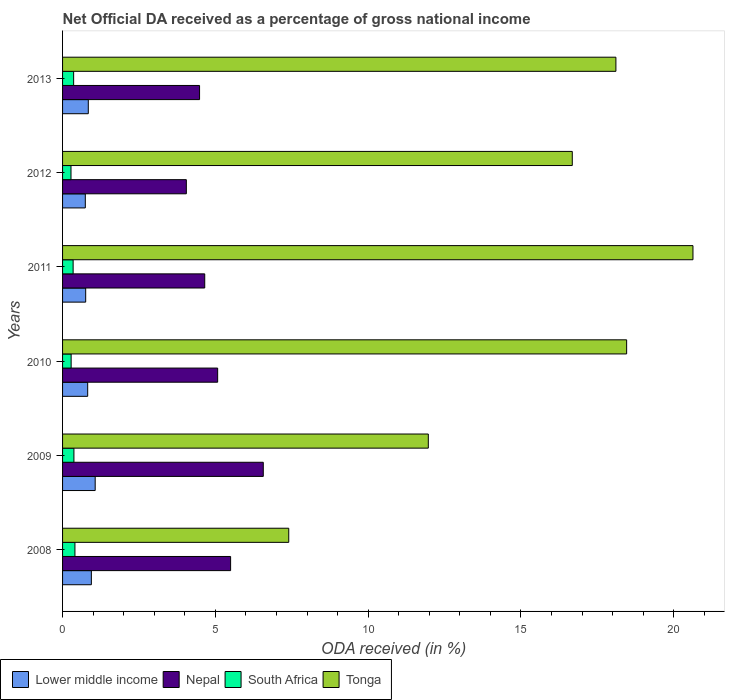How many bars are there on the 6th tick from the top?
Provide a short and direct response. 4. What is the label of the 2nd group of bars from the top?
Give a very brief answer. 2012. What is the net official DA received in Tonga in 2009?
Make the answer very short. 11.97. Across all years, what is the maximum net official DA received in Tonga?
Your answer should be compact. 20.63. Across all years, what is the minimum net official DA received in Nepal?
Provide a succinct answer. 4.05. In which year was the net official DA received in Nepal minimum?
Keep it short and to the point. 2012. What is the total net official DA received in Tonga in the graph?
Your response must be concise. 93.24. What is the difference between the net official DA received in Nepal in 2009 and that in 2013?
Your answer should be very brief. 2.08. What is the difference between the net official DA received in Nepal in 2010 and the net official DA received in Lower middle income in 2008?
Provide a succinct answer. 4.13. What is the average net official DA received in South Africa per year?
Provide a short and direct response. 0.34. In the year 2012, what is the difference between the net official DA received in Lower middle income and net official DA received in South Africa?
Provide a short and direct response. 0.47. In how many years, is the net official DA received in South Africa greater than 11 %?
Offer a very short reply. 0. What is the ratio of the net official DA received in South Africa in 2010 to that in 2012?
Make the answer very short. 1.02. Is the difference between the net official DA received in Lower middle income in 2008 and 2012 greater than the difference between the net official DA received in South Africa in 2008 and 2012?
Make the answer very short. Yes. What is the difference between the highest and the second highest net official DA received in Lower middle income?
Provide a short and direct response. 0.13. What is the difference between the highest and the lowest net official DA received in Nepal?
Provide a succinct answer. 2.52. Is the sum of the net official DA received in Tonga in 2010 and 2013 greater than the maximum net official DA received in Nepal across all years?
Provide a succinct answer. Yes. Is it the case that in every year, the sum of the net official DA received in Nepal and net official DA received in Tonga is greater than the sum of net official DA received in South Africa and net official DA received in Lower middle income?
Give a very brief answer. Yes. What does the 3rd bar from the top in 2008 represents?
Provide a short and direct response. Nepal. What does the 4th bar from the bottom in 2009 represents?
Keep it short and to the point. Tonga. Is it the case that in every year, the sum of the net official DA received in Lower middle income and net official DA received in Tonga is greater than the net official DA received in South Africa?
Offer a very short reply. Yes. How many years are there in the graph?
Provide a succinct answer. 6. Are the values on the major ticks of X-axis written in scientific E-notation?
Your answer should be very brief. No. Does the graph contain grids?
Offer a very short reply. No. How are the legend labels stacked?
Offer a terse response. Horizontal. What is the title of the graph?
Make the answer very short. Net Official DA received as a percentage of gross national income. What is the label or title of the X-axis?
Ensure brevity in your answer.  ODA received (in %). What is the ODA received (in %) in Lower middle income in 2008?
Provide a succinct answer. 0.94. What is the ODA received (in %) of Nepal in 2008?
Your answer should be very brief. 5.5. What is the ODA received (in %) in South Africa in 2008?
Ensure brevity in your answer.  0.4. What is the ODA received (in %) in Tonga in 2008?
Your answer should be compact. 7.4. What is the ODA received (in %) in Lower middle income in 2009?
Keep it short and to the point. 1.07. What is the ODA received (in %) of Nepal in 2009?
Ensure brevity in your answer.  6.57. What is the ODA received (in %) of South Africa in 2009?
Offer a very short reply. 0.37. What is the ODA received (in %) in Tonga in 2009?
Offer a terse response. 11.97. What is the ODA received (in %) of Lower middle income in 2010?
Make the answer very short. 0.82. What is the ODA received (in %) in Nepal in 2010?
Your answer should be compact. 5.08. What is the ODA received (in %) in South Africa in 2010?
Offer a terse response. 0.28. What is the ODA received (in %) in Tonga in 2010?
Ensure brevity in your answer.  18.46. What is the ODA received (in %) in Lower middle income in 2011?
Make the answer very short. 0.76. What is the ODA received (in %) in Nepal in 2011?
Provide a short and direct response. 4.65. What is the ODA received (in %) in South Africa in 2011?
Keep it short and to the point. 0.35. What is the ODA received (in %) of Tonga in 2011?
Your response must be concise. 20.63. What is the ODA received (in %) in Lower middle income in 2012?
Keep it short and to the point. 0.74. What is the ODA received (in %) of Nepal in 2012?
Make the answer very short. 4.05. What is the ODA received (in %) in South Africa in 2012?
Your answer should be very brief. 0.28. What is the ODA received (in %) of Tonga in 2012?
Give a very brief answer. 16.68. What is the ODA received (in %) in Lower middle income in 2013?
Your answer should be very brief. 0.84. What is the ODA received (in %) in Nepal in 2013?
Give a very brief answer. 4.48. What is the ODA received (in %) of South Africa in 2013?
Provide a short and direct response. 0.36. What is the ODA received (in %) of Tonga in 2013?
Ensure brevity in your answer.  18.11. Across all years, what is the maximum ODA received (in %) in Lower middle income?
Give a very brief answer. 1.07. Across all years, what is the maximum ODA received (in %) of Nepal?
Your response must be concise. 6.57. Across all years, what is the maximum ODA received (in %) of South Africa?
Keep it short and to the point. 0.4. Across all years, what is the maximum ODA received (in %) of Tonga?
Provide a succinct answer. 20.63. Across all years, what is the minimum ODA received (in %) in Lower middle income?
Keep it short and to the point. 0.74. Across all years, what is the minimum ODA received (in %) of Nepal?
Offer a very short reply. 4.05. Across all years, what is the minimum ODA received (in %) in South Africa?
Ensure brevity in your answer.  0.28. Across all years, what is the minimum ODA received (in %) of Tonga?
Make the answer very short. 7.4. What is the total ODA received (in %) in Lower middle income in the graph?
Offer a terse response. 5.17. What is the total ODA received (in %) in Nepal in the graph?
Ensure brevity in your answer.  30.33. What is the total ODA received (in %) of South Africa in the graph?
Offer a terse response. 2.04. What is the total ODA received (in %) of Tonga in the graph?
Your answer should be very brief. 93.24. What is the difference between the ODA received (in %) of Lower middle income in 2008 and that in 2009?
Your answer should be compact. -0.13. What is the difference between the ODA received (in %) of Nepal in 2008 and that in 2009?
Give a very brief answer. -1.07. What is the difference between the ODA received (in %) in South Africa in 2008 and that in 2009?
Offer a very short reply. 0.03. What is the difference between the ODA received (in %) in Tonga in 2008 and that in 2009?
Ensure brevity in your answer.  -4.57. What is the difference between the ODA received (in %) in Lower middle income in 2008 and that in 2010?
Keep it short and to the point. 0.12. What is the difference between the ODA received (in %) of Nepal in 2008 and that in 2010?
Offer a terse response. 0.42. What is the difference between the ODA received (in %) of South Africa in 2008 and that in 2010?
Provide a succinct answer. 0.12. What is the difference between the ODA received (in %) of Tonga in 2008 and that in 2010?
Keep it short and to the point. -11.06. What is the difference between the ODA received (in %) of Lower middle income in 2008 and that in 2011?
Offer a terse response. 0.19. What is the difference between the ODA received (in %) in Nepal in 2008 and that in 2011?
Your answer should be compact. 0.85. What is the difference between the ODA received (in %) of South Africa in 2008 and that in 2011?
Offer a terse response. 0.06. What is the difference between the ODA received (in %) in Tonga in 2008 and that in 2011?
Make the answer very short. -13.23. What is the difference between the ODA received (in %) of Lower middle income in 2008 and that in 2012?
Provide a short and direct response. 0.2. What is the difference between the ODA received (in %) in Nepal in 2008 and that in 2012?
Your answer should be very brief. 1.45. What is the difference between the ODA received (in %) in South Africa in 2008 and that in 2012?
Ensure brevity in your answer.  0.13. What is the difference between the ODA received (in %) of Tonga in 2008 and that in 2012?
Offer a terse response. -9.28. What is the difference between the ODA received (in %) in Lower middle income in 2008 and that in 2013?
Offer a very short reply. 0.1. What is the difference between the ODA received (in %) of Nepal in 2008 and that in 2013?
Ensure brevity in your answer.  1.02. What is the difference between the ODA received (in %) of South Africa in 2008 and that in 2013?
Provide a short and direct response. 0.04. What is the difference between the ODA received (in %) in Tonga in 2008 and that in 2013?
Ensure brevity in your answer.  -10.71. What is the difference between the ODA received (in %) of Lower middle income in 2009 and that in 2010?
Your answer should be compact. 0.25. What is the difference between the ODA received (in %) in Nepal in 2009 and that in 2010?
Make the answer very short. 1.49. What is the difference between the ODA received (in %) in South Africa in 2009 and that in 2010?
Your answer should be very brief. 0.09. What is the difference between the ODA received (in %) in Tonga in 2009 and that in 2010?
Make the answer very short. -6.49. What is the difference between the ODA received (in %) in Lower middle income in 2009 and that in 2011?
Give a very brief answer. 0.31. What is the difference between the ODA received (in %) in Nepal in 2009 and that in 2011?
Make the answer very short. 1.92. What is the difference between the ODA received (in %) of South Africa in 2009 and that in 2011?
Make the answer very short. 0.03. What is the difference between the ODA received (in %) in Tonga in 2009 and that in 2011?
Offer a very short reply. -8.66. What is the difference between the ODA received (in %) of Lower middle income in 2009 and that in 2012?
Keep it short and to the point. 0.32. What is the difference between the ODA received (in %) in Nepal in 2009 and that in 2012?
Give a very brief answer. 2.52. What is the difference between the ODA received (in %) in South Africa in 2009 and that in 2012?
Make the answer very short. 0.1. What is the difference between the ODA received (in %) in Tonga in 2009 and that in 2012?
Ensure brevity in your answer.  -4.71. What is the difference between the ODA received (in %) of Lower middle income in 2009 and that in 2013?
Offer a very short reply. 0.23. What is the difference between the ODA received (in %) in Nepal in 2009 and that in 2013?
Your answer should be compact. 2.08. What is the difference between the ODA received (in %) in South Africa in 2009 and that in 2013?
Keep it short and to the point. 0.01. What is the difference between the ODA received (in %) of Tonga in 2009 and that in 2013?
Your response must be concise. -6.14. What is the difference between the ODA received (in %) in Lower middle income in 2010 and that in 2011?
Offer a very short reply. 0.07. What is the difference between the ODA received (in %) in Nepal in 2010 and that in 2011?
Offer a terse response. 0.42. What is the difference between the ODA received (in %) in South Africa in 2010 and that in 2011?
Your response must be concise. -0.07. What is the difference between the ODA received (in %) of Tonga in 2010 and that in 2011?
Offer a terse response. -2.17. What is the difference between the ODA received (in %) in Lower middle income in 2010 and that in 2012?
Your answer should be compact. 0.08. What is the difference between the ODA received (in %) of Nepal in 2010 and that in 2012?
Your response must be concise. 1.02. What is the difference between the ODA received (in %) of South Africa in 2010 and that in 2012?
Give a very brief answer. 0. What is the difference between the ODA received (in %) of Tonga in 2010 and that in 2012?
Offer a terse response. 1.78. What is the difference between the ODA received (in %) of Lower middle income in 2010 and that in 2013?
Offer a very short reply. -0.02. What is the difference between the ODA received (in %) in Nepal in 2010 and that in 2013?
Your answer should be very brief. 0.59. What is the difference between the ODA received (in %) of South Africa in 2010 and that in 2013?
Keep it short and to the point. -0.08. What is the difference between the ODA received (in %) of Tonga in 2010 and that in 2013?
Offer a very short reply. 0.35. What is the difference between the ODA received (in %) of Lower middle income in 2011 and that in 2012?
Your answer should be very brief. 0.01. What is the difference between the ODA received (in %) in Nepal in 2011 and that in 2012?
Your response must be concise. 0.6. What is the difference between the ODA received (in %) in South Africa in 2011 and that in 2012?
Your answer should be compact. 0.07. What is the difference between the ODA received (in %) of Tonga in 2011 and that in 2012?
Provide a succinct answer. 3.95. What is the difference between the ODA received (in %) in Lower middle income in 2011 and that in 2013?
Your answer should be compact. -0.09. What is the difference between the ODA received (in %) in Nepal in 2011 and that in 2013?
Your response must be concise. 0.17. What is the difference between the ODA received (in %) in South Africa in 2011 and that in 2013?
Your response must be concise. -0.02. What is the difference between the ODA received (in %) in Tonga in 2011 and that in 2013?
Offer a terse response. 2.52. What is the difference between the ODA received (in %) in Lower middle income in 2012 and that in 2013?
Provide a short and direct response. -0.1. What is the difference between the ODA received (in %) in Nepal in 2012 and that in 2013?
Your answer should be very brief. -0.43. What is the difference between the ODA received (in %) of South Africa in 2012 and that in 2013?
Your answer should be compact. -0.09. What is the difference between the ODA received (in %) in Tonga in 2012 and that in 2013?
Keep it short and to the point. -1.43. What is the difference between the ODA received (in %) in Lower middle income in 2008 and the ODA received (in %) in Nepal in 2009?
Your answer should be compact. -5.63. What is the difference between the ODA received (in %) of Lower middle income in 2008 and the ODA received (in %) of South Africa in 2009?
Your response must be concise. 0.57. What is the difference between the ODA received (in %) in Lower middle income in 2008 and the ODA received (in %) in Tonga in 2009?
Make the answer very short. -11.03. What is the difference between the ODA received (in %) of Nepal in 2008 and the ODA received (in %) of South Africa in 2009?
Offer a very short reply. 5.13. What is the difference between the ODA received (in %) in Nepal in 2008 and the ODA received (in %) in Tonga in 2009?
Offer a very short reply. -6.47. What is the difference between the ODA received (in %) in South Africa in 2008 and the ODA received (in %) in Tonga in 2009?
Keep it short and to the point. -11.56. What is the difference between the ODA received (in %) of Lower middle income in 2008 and the ODA received (in %) of Nepal in 2010?
Your response must be concise. -4.13. What is the difference between the ODA received (in %) in Lower middle income in 2008 and the ODA received (in %) in South Africa in 2010?
Give a very brief answer. 0.66. What is the difference between the ODA received (in %) of Lower middle income in 2008 and the ODA received (in %) of Tonga in 2010?
Offer a terse response. -17.52. What is the difference between the ODA received (in %) in Nepal in 2008 and the ODA received (in %) in South Africa in 2010?
Your answer should be compact. 5.22. What is the difference between the ODA received (in %) of Nepal in 2008 and the ODA received (in %) of Tonga in 2010?
Provide a short and direct response. -12.96. What is the difference between the ODA received (in %) of South Africa in 2008 and the ODA received (in %) of Tonga in 2010?
Provide a short and direct response. -18.05. What is the difference between the ODA received (in %) of Lower middle income in 2008 and the ODA received (in %) of Nepal in 2011?
Keep it short and to the point. -3.71. What is the difference between the ODA received (in %) in Lower middle income in 2008 and the ODA received (in %) in South Africa in 2011?
Give a very brief answer. 0.6. What is the difference between the ODA received (in %) of Lower middle income in 2008 and the ODA received (in %) of Tonga in 2011?
Keep it short and to the point. -19.69. What is the difference between the ODA received (in %) of Nepal in 2008 and the ODA received (in %) of South Africa in 2011?
Ensure brevity in your answer.  5.15. What is the difference between the ODA received (in %) in Nepal in 2008 and the ODA received (in %) in Tonga in 2011?
Offer a terse response. -15.13. What is the difference between the ODA received (in %) in South Africa in 2008 and the ODA received (in %) in Tonga in 2011?
Your response must be concise. -20.22. What is the difference between the ODA received (in %) of Lower middle income in 2008 and the ODA received (in %) of Nepal in 2012?
Your answer should be very brief. -3.11. What is the difference between the ODA received (in %) in Lower middle income in 2008 and the ODA received (in %) in South Africa in 2012?
Your answer should be very brief. 0.67. What is the difference between the ODA received (in %) in Lower middle income in 2008 and the ODA received (in %) in Tonga in 2012?
Offer a very short reply. -15.74. What is the difference between the ODA received (in %) in Nepal in 2008 and the ODA received (in %) in South Africa in 2012?
Your answer should be compact. 5.22. What is the difference between the ODA received (in %) in Nepal in 2008 and the ODA received (in %) in Tonga in 2012?
Offer a very short reply. -11.18. What is the difference between the ODA received (in %) in South Africa in 2008 and the ODA received (in %) in Tonga in 2012?
Offer a very short reply. -16.27. What is the difference between the ODA received (in %) in Lower middle income in 2008 and the ODA received (in %) in Nepal in 2013?
Your response must be concise. -3.54. What is the difference between the ODA received (in %) in Lower middle income in 2008 and the ODA received (in %) in South Africa in 2013?
Offer a very short reply. 0.58. What is the difference between the ODA received (in %) of Lower middle income in 2008 and the ODA received (in %) of Tonga in 2013?
Your answer should be very brief. -17.16. What is the difference between the ODA received (in %) in Nepal in 2008 and the ODA received (in %) in South Africa in 2013?
Your answer should be very brief. 5.14. What is the difference between the ODA received (in %) in Nepal in 2008 and the ODA received (in %) in Tonga in 2013?
Make the answer very short. -12.61. What is the difference between the ODA received (in %) of South Africa in 2008 and the ODA received (in %) of Tonga in 2013?
Make the answer very short. -17.7. What is the difference between the ODA received (in %) in Lower middle income in 2009 and the ODA received (in %) in Nepal in 2010?
Provide a succinct answer. -4.01. What is the difference between the ODA received (in %) of Lower middle income in 2009 and the ODA received (in %) of South Africa in 2010?
Keep it short and to the point. 0.79. What is the difference between the ODA received (in %) of Lower middle income in 2009 and the ODA received (in %) of Tonga in 2010?
Offer a terse response. -17.39. What is the difference between the ODA received (in %) of Nepal in 2009 and the ODA received (in %) of South Africa in 2010?
Your answer should be compact. 6.29. What is the difference between the ODA received (in %) in Nepal in 2009 and the ODA received (in %) in Tonga in 2010?
Provide a short and direct response. -11.89. What is the difference between the ODA received (in %) in South Africa in 2009 and the ODA received (in %) in Tonga in 2010?
Keep it short and to the point. -18.09. What is the difference between the ODA received (in %) in Lower middle income in 2009 and the ODA received (in %) in Nepal in 2011?
Offer a very short reply. -3.58. What is the difference between the ODA received (in %) in Lower middle income in 2009 and the ODA received (in %) in South Africa in 2011?
Provide a succinct answer. 0.72. What is the difference between the ODA received (in %) in Lower middle income in 2009 and the ODA received (in %) in Tonga in 2011?
Provide a short and direct response. -19.56. What is the difference between the ODA received (in %) of Nepal in 2009 and the ODA received (in %) of South Africa in 2011?
Ensure brevity in your answer.  6.22. What is the difference between the ODA received (in %) of Nepal in 2009 and the ODA received (in %) of Tonga in 2011?
Offer a very short reply. -14.06. What is the difference between the ODA received (in %) of South Africa in 2009 and the ODA received (in %) of Tonga in 2011?
Make the answer very short. -20.26. What is the difference between the ODA received (in %) in Lower middle income in 2009 and the ODA received (in %) in Nepal in 2012?
Offer a terse response. -2.98. What is the difference between the ODA received (in %) of Lower middle income in 2009 and the ODA received (in %) of South Africa in 2012?
Provide a short and direct response. 0.79. What is the difference between the ODA received (in %) in Lower middle income in 2009 and the ODA received (in %) in Tonga in 2012?
Provide a succinct answer. -15.61. What is the difference between the ODA received (in %) of Nepal in 2009 and the ODA received (in %) of South Africa in 2012?
Give a very brief answer. 6.29. What is the difference between the ODA received (in %) in Nepal in 2009 and the ODA received (in %) in Tonga in 2012?
Keep it short and to the point. -10.11. What is the difference between the ODA received (in %) of South Africa in 2009 and the ODA received (in %) of Tonga in 2012?
Provide a succinct answer. -16.31. What is the difference between the ODA received (in %) of Lower middle income in 2009 and the ODA received (in %) of Nepal in 2013?
Provide a short and direct response. -3.42. What is the difference between the ODA received (in %) in Lower middle income in 2009 and the ODA received (in %) in South Africa in 2013?
Keep it short and to the point. 0.7. What is the difference between the ODA received (in %) in Lower middle income in 2009 and the ODA received (in %) in Tonga in 2013?
Provide a short and direct response. -17.04. What is the difference between the ODA received (in %) in Nepal in 2009 and the ODA received (in %) in South Africa in 2013?
Offer a terse response. 6.21. What is the difference between the ODA received (in %) in Nepal in 2009 and the ODA received (in %) in Tonga in 2013?
Keep it short and to the point. -11.54. What is the difference between the ODA received (in %) of South Africa in 2009 and the ODA received (in %) of Tonga in 2013?
Ensure brevity in your answer.  -17.73. What is the difference between the ODA received (in %) of Lower middle income in 2010 and the ODA received (in %) of Nepal in 2011?
Your answer should be compact. -3.83. What is the difference between the ODA received (in %) of Lower middle income in 2010 and the ODA received (in %) of South Africa in 2011?
Your answer should be compact. 0.48. What is the difference between the ODA received (in %) in Lower middle income in 2010 and the ODA received (in %) in Tonga in 2011?
Make the answer very short. -19.81. What is the difference between the ODA received (in %) in Nepal in 2010 and the ODA received (in %) in South Africa in 2011?
Your response must be concise. 4.73. What is the difference between the ODA received (in %) in Nepal in 2010 and the ODA received (in %) in Tonga in 2011?
Provide a short and direct response. -15.55. What is the difference between the ODA received (in %) in South Africa in 2010 and the ODA received (in %) in Tonga in 2011?
Offer a very short reply. -20.35. What is the difference between the ODA received (in %) of Lower middle income in 2010 and the ODA received (in %) of Nepal in 2012?
Provide a succinct answer. -3.23. What is the difference between the ODA received (in %) in Lower middle income in 2010 and the ODA received (in %) in South Africa in 2012?
Your answer should be very brief. 0.55. What is the difference between the ODA received (in %) in Lower middle income in 2010 and the ODA received (in %) in Tonga in 2012?
Make the answer very short. -15.86. What is the difference between the ODA received (in %) in Nepal in 2010 and the ODA received (in %) in South Africa in 2012?
Your answer should be compact. 4.8. What is the difference between the ODA received (in %) in Nepal in 2010 and the ODA received (in %) in Tonga in 2012?
Keep it short and to the point. -11.6. What is the difference between the ODA received (in %) in South Africa in 2010 and the ODA received (in %) in Tonga in 2012?
Your answer should be very brief. -16.4. What is the difference between the ODA received (in %) of Lower middle income in 2010 and the ODA received (in %) of Nepal in 2013?
Your answer should be compact. -3.66. What is the difference between the ODA received (in %) in Lower middle income in 2010 and the ODA received (in %) in South Africa in 2013?
Your response must be concise. 0.46. What is the difference between the ODA received (in %) in Lower middle income in 2010 and the ODA received (in %) in Tonga in 2013?
Provide a short and direct response. -17.28. What is the difference between the ODA received (in %) of Nepal in 2010 and the ODA received (in %) of South Africa in 2013?
Your answer should be compact. 4.71. What is the difference between the ODA received (in %) in Nepal in 2010 and the ODA received (in %) in Tonga in 2013?
Ensure brevity in your answer.  -13.03. What is the difference between the ODA received (in %) in South Africa in 2010 and the ODA received (in %) in Tonga in 2013?
Keep it short and to the point. -17.83. What is the difference between the ODA received (in %) in Lower middle income in 2011 and the ODA received (in %) in Nepal in 2012?
Ensure brevity in your answer.  -3.29. What is the difference between the ODA received (in %) in Lower middle income in 2011 and the ODA received (in %) in South Africa in 2012?
Keep it short and to the point. 0.48. What is the difference between the ODA received (in %) of Lower middle income in 2011 and the ODA received (in %) of Tonga in 2012?
Provide a short and direct response. -15.92. What is the difference between the ODA received (in %) in Nepal in 2011 and the ODA received (in %) in South Africa in 2012?
Ensure brevity in your answer.  4.38. What is the difference between the ODA received (in %) of Nepal in 2011 and the ODA received (in %) of Tonga in 2012?
Offer a very short reply. -12.03. What is the difference between the ODA received (in %) of South Africa in 2011 and the ODA received (in %) of Tonga in 2012?
Give a very brief answer. -16.33. What is the difference between the ODA received (in %) of Lower middle income in 2011 and the ODA received (in %) of Nepal in 2013?
Your response must be concise. -3.73. What is the difference between the ODA received (in %) in Lower middle income in 2011 and the ODA received (in %) in South Africa in 2013?
Make the answer very short. 0.39. What is the difference between the ODA received (in %) in Lower middle income in 2011 and the ODA received (in %) in Tonga in 2013?
Give a very brief answer. -17.35. What is the difference between the ODA received (in %) of Nepal in 2011 and the ODA received (in %) of South Africa in 2013?
Your answer should be compact. 4.29. What is the difference between the ODA received (in %) of Nepal in 2011 and the ODA received (in %) of Tonga in 2013?
Provide a succinct answer. -13.45. What is the difference between the ODA received (in %) in South Africa in 2011 and the ODA received (in %) in Tonga in 2013?
Offer a very short reply. -17.76. What is the difference between the ODA received (in %) in Lower middle income in 2012 and the ODA received (in %) in Nepal in 2013?
Provide a succinct answer. -3.74. What is the difference between the ODA received (in %) in Lower middle income in 2012 and the ODA received (in %) in South Africa in 2013?
Make the answer very short. 0.38. What is the difference between the ODA received (in %) of Lower middle income in 2012 and the ODA received (in %) of Tonga in 2013?
Give a very brief answer. -17.36. What is the difference between the ODA received (in %) in Nepal in 2012 and the ODA received (in %) in South Africa in 2013?
Your answer should be very brief. 3.69. What is the difference between the ODA received (in %) in Nepal in 2012 and the ODA received (in %) in Tonga in 2013?
Make the answer very short. -14.06. What is the difference between the ODA received (in %) of South Africa in 2012 and the ODA received (in %) of Tonga in 2013?
Give a very brief answer. -17.83. What is the average ODA received (in %) of Lower middle income per year?
Keep it short and to the point. 0.86. What is the average ODA received (in %) of Nepal per year?
Your answer should be compact. 5.05. What is the average ODA received (in %) in South Africa per year?
Offer a terse response. 0.34. What is the average ODA received (in %) in Tonga per year?
Your response must be concise. 15.54. In the year 2008, what is the difference between the ODA received (in %) of Lower middle income and ODA received (in %) of Nepal?
Keep it short and to the point. -4.56. In the year 2008, what is the difference between the ODA received (in %) in Lower middle income and ODA received (in %) in South Africa?
Provide a short and direct response. 0.54. In the year 2008, what is the difference between the ODA received (in %) of Lower middle income and ODA received (in %) of Tonga?
Give a very brief answer. -6.46. In the year 2008, what is the difference between the ODA received (in %) of Nepal and ODA received (in %) of South Africa?
Keep it short and to the point. 5.09. In the year 2008, what is the difference between the ODA received (in %) of Nepal and ODA received (in %) of Tonga?
Keep it short and to the point. -1.9. In the year 2008, what is the difference between the ODA received (in %) in South Africa and ODA received (in %) in Tonga?
Make the answer very short. -7. In the year 2009, what is the difference between the ODA received (in %) in Lower middle income and ODA received (in %) in Nepal?
Your response must be concise. -5.5. In the year 2009, what is the difference between the ODA received (in %) of Lower middle income and ODA received (in %) of South Africa?
Provide a succinct answer. 0.7. In the year 2009, what is the difference between the ODA received (in %) of Lower middle income and ODA received (in %) of Tonga?
Your answer should be very brief. -10.9. In the year 2009, what is the difference between the ODA received (in %) in Nepal and ODA received (in %) in South Africa?
Give a very brief answer. 6.2. In the year 2009, what is the difference between the ODA received (in %) of Nepal and ODA received (in %) of Tonga?
Offer a terse response. -5.4. In the year 2009, what is the difference between the ODA received (in %) in South Africa and ODA received (in %) in Tonga?
Offer a very short reply. -11.6. In the year 2010, what is the difference between the ODA received (in %) in Lower middle income and ODA received (in %) in Nepal?
Keep it short and to the point. -4.25. In the year 2010, what is the difference between the ODA received (in %) in Lower middle income and ODA received (in %) in South Africa?
Ensure brevity in your answer.  0.54. In the year 2010, what is the difference between the ODA received (in %) in Lower middle income and ODA received (in %) in Tonga?
Your answer should be very brief. -17.64. In the year 2010, what is the difference between the ODA received (in %) in Nepal and ODA received (in %) in South Africa?
Offer a very short reply. 4.79. In the year 2010, what is the difference between the ODA received (in %) of Nepal and ODA received (in %) of Tonga?
Your response must be concise. -13.38. In the year 2010, what is the difference between the ODA received (in %) of South Africa and ODA received (in %) of Tonga?
Make the answer very short. -18.18. In the year 2011, what is the difference between the ODA received (in %) of Lower middle income and ODA received (in %) of Nepal?
Your response must be concise. -3.9. In the year 2011, what is the difference between the ODA received (in %) of Lower middle income and ODA received (in %) of South Africa?
Make the answer very short. 0.41. In the year 2011, what is the difference between the ODA received (in %) of Lower middle income and ODA received (in %) of Tonga?
Your response must be concise. -19.87. In the year 2011, what is the difference between the ODA received (in %) in Nepal and ODA received (in %) in South Africa?
Keep it short and to the point. 4.31. In the year 2011, what is the difference between the ODA received (in %) of Nepal and ODA received (in %) of Tonga?
Make the answer very short. -15.98. In the year 2011, what is the difference between the ODA received (in %) of South Africa and ODA received (in %) of Tonga?
Offer a terse response. -20.28. In the year 2012, what is the difference between the ODA received (in %) of Lower middle income and ODA received (in %) of Nepal?
Your answer should be very brief. -3.31. In the year 2012, what is the difference between the ODA received (in %) of Lower middle income and ODA received (in %) of South Africa?
Offer a terse response. 0.47. In the year 2012, what is the difference between the ODA received (in %) of Lower middle income and ODA received (in %) of Tonga?
Keep it short and to the point. -15.93. In the year 2012, what is the difference between the ODA received (in %) of Nepal and ODA received (in %) of South Africa?
Offer a very short reply. 3.77. In the year 2012, what is the difference between the ODA received (in %) of Nepal and ODA received (in %) of Tonga?
Keep it short and to the point. -12.63. In the year 2012, what is the difference between the ODA received (in %) of South Africa and ODA received (in %) of Tonga?
Provide a short and direct response. -16.4. In the year 2013, what is the difference between the ODA received (in %) of Lower middle income and ODA received (in %) of Nepal?
Offer a terse response. -3.64. In the year 2013, what is the difference between the ODA received (in %) in Lower middle income and ODA received (in %) in South Africa?
Provide a succinct answer. 0.48. In the year 2013, what is the difference between the ODA received (in %) in Lower middle income and ODA received (in %) in Tonga?
Offer a terse response. -17.26. In the year 2013, what is the difference between the ODA received (in %) in Nepal and ODA received (in %) in South Africa?
Ensure brevity in your answer.  4.12. In the year 2013, what is the difference between the ODA received (in %) of Nepal and ODA received (in %) of Tonga?
Your answer should be compact. -13.62. In the year 2013, what is the difference between the ODA received (in %) in South Africa and ODA received (in %) in Tonga?
Your response must be concise. -17.74. What is the ratio of the ODA received (in %) of Lower middle income in 2008 to that in 2009?
Your answer should be very brief. 0.88. What is the ratio of the ODA received (in %) in Nepal in 2008 to that in 2009?
Give a very brief answer. 0.84. What is the ratio of the ODA received (in %) in South Africa in 2008 to that in 2009?
Provide a succinct answer. 1.09. What is the ratio of the ODA received (in %) in Tonga in 2008 to that in 2009?
Keep it short and to the point. 0.62. What is the ratio of the ODA received (in %) of Lower middle income in 2008 to that in 2010?
Provide a short and direct response. 1.15. What is the ratio of the ODA received (in %) of Nepal in 2008 to that in 2010?
Make the answer very short. 1.08. What is the ratio of the ODA received (in %) in South Africa in 2008 to that in 2010?
Ensure brevity in your answer.  1.44. What is the ratio of the ODA received (in %) of Tonga in 2008 to that in 2010?
Your answer should be compact. 0.4. What is the ratio of the ODA received (in %) in Lower middle income in 2008 to that in 2011?
Your answer should be very brief. 1.25. What is the ratio of the ODA received (in %) of Nepal in 2008 to that in 2011?
Offer a terse response. 1.18. What is the ratio of the ODA received (in %) in South Africa in 2008 to that in 2011?
Your answer should be compact. 1.17. What is the ratio of the ODA received (in %) in Tonga in 2008 to that in 2011?
Your answer should be very brief. 0.36. What is the ratio of the ODA received (in %) of Lower middle income in 2008 to that in 2012?
Make the answer very short. 1.27. What is the ratio of the ODA received (in %) in Nepal in 2008 to that in 2012?
Offer a very short reply. 1.36. What is the ratio of the ODA received (in %) of South Africa in 2008 to that in 2012?
Offer a terse response. 1.47. What is the ratio of the ODA received (in %) in Tonga in 2008 to that in 2012?
Ensure brevity in your answer.  0.44. What is the ratio of the ODA received (in %) in Lower middle income in 2008 to that in 2013?
Offer a terse response. 1.12. What is the ratio of the ODA received (in %) of Nepal in 2008 to that in 2013?
Make the answer very short. 1.23. What is the ratio of the ODA received (in %) of South Africa in 2008 to that in 2013?
Your answer should be very brief. 1.12. What is the ratio of the ODA received (in %) of Tonga in 2008 to that in 2013?
Offer a very short reply. 0.41. What is the ratio of the ODA received (in %) of Lower middle income in 2009 to that in 2010?
Give a very brief answer. 1.3. What is the ratio of the ODA received (in %) of Nepal in 2009 to that in 2010?
Ensure brevity in your answer.  1.29. What is the ratio of the ODA received (in %) in South Africa in 2009 to that in 2010?
Give a very brief answer. 1.32. What is the ratio of the ODA received (in %) of Tonga in 2009 to that in 2010?
Provide a short and direct response. 0.65. What is the ratio of the ODA received (in %) in Lower middle income in 2009 to that in 2011?
Make the answer very short. 1.41. What is the ratio of the ODA received (in %) in Nepal in 2009 to that in 2011?
Offer a very short reply. 1.41. What is the ratio of the ODA received (in %) in South Africa in 2009 to that in 2011?
Ensure brevity in your answer.  1.07. What is the ratio of the ODA received (in %) in Tonga in 2009 to that in 2011?
Offer a terse response. 0.58. What is the ratio of the ODA received (in %) in Lower middle income in 2009 to that in 2012?
Provide a succinct answer. 1.43. What is the ratio of the ODA received (in %) in Nepal in 2009 to that in 2012?
Ensure brevity in your answer.  1.62. What is the ratio of the ODA received (in %) in South Africa in 2009 to that in 2012?
Provide a succinct answer. 1.35. What is the ratio of the ODA received (in %) of Tonga in 2009 to that in 2012?
Give a very brief answer. 0.72. What is the ratio of the ODA received (in %) of Lower middle income in 2009 to that in 2013?
Provide a succinct answer. 1.27. What is the ratio of the ODA received (in %) of Nepal in 2009 to that in 2013?
Your response must be concise. 1.47. What is the ratio of the ODA received (in %) in South Africa in 2009 to that in 2013?
Provide a succinct answer. 1.02. What is the ratio of the ODA received (in %) in Tonga in 2009 to that in 2013?
Give a very brief answer. 0.66. What is the ratio of the ODA received (in %) in Lower middle income in 2010 to that in 2011?
Keep it short and to the point. 1.09. What is the ratio of the ODA received (in %) in South Africa in 2010 to that in 2011?
Offer a terse response. 0.81. What is the ratio of the ODA received (in %) in Tonga in 2010 to that in 2011?
Give a very brief answer. 0.89. What is the ratio of the ODA received (in %) in Lower middle income in 2010 to that in 2012?
Make the answer very short. 1.1. What is the ratio of the ODA received (in %) in Nepal in 2010 to that in 2012?
Your response must be concise. 1.25. What is the ratio of the ODA received (in %) of South Africa in 2010 to that in 2012?
Your response must be concise. 1.02. What is the ratio of the ODA received (in %) in Tonga in 2010 to that in 2012?
Your answer should be very brief. 1.11. What is the ratio of the ODA received (in %) in Lower middle income in 2010 to that in 2013?
Your answer should be compact. 0.98. What is the ratio of the ODA received (in %) in Nepal in 2010 to that in 2013?
Your response must be concise. 1.13. What is the ratio of the ODA received (in %) in South Africa in 2010 to that in 2013?
Your response must be concise. 0.77. What is the ratio of the ODA received (in %) of Tonga in 2010 to that in 2013?
Make the answer very short. 1.02. What is the ratio of the ODA received (in %) in Lower middle income in 2011 to that in 2012?
Offer a very short reply. 1.02. What is the ratio of the ODA received (in %) in Nepal in 2011 to that in 2012?
Provide a succinct answer. 1.15. What is the ratio of the ODA received (in %) of South Africa in 2011 to that in 2012?
Your response must be concise. 1.25. What is the ratio of the ODA received (in %) of Tonga in 2011 to that in 2012?
Your response must be concise. 1.24. What is the ratio of the ODA received (in %) of Lower middle income in 2011 to that in 2013?
Keep it short and to the point. 0.9. What is the ratio of the ODA received (in %) of Nepal in 2011 to that in 2013?
Provide a short and direct response. 1.04. What is the ratio of the ODA received (in %) of South Africa in 2011 to that in 2013?
Keep it short and to the point. 0.95. What is the ratio of the ODA received (in %) of Tonga in 2011 to that in 2013?
Provide a short and direct response. 1.14. What is the ratio of the ODA received (in %) of Lower middle income in 2012 to that in 2013?
Offer a terse response. 0.88. What is the ratio of the ODA received (in %) of Nepal in 2012 to that in 2013?
Provide a short and direct response. 0.9. What is the ratio of the ODA received (in %) of South Africa in 2012 to that in 2013?
Give a very brief answer. 0.76. What is the ratio of the ODA received (in %) in Tonga in 2012 to that in 2013?
Your answer should be very brief. 0.92. What is the difference between the highest and the second highest ODA received (in %) of Lower middle income?
Provide a short and direct response. 0.13. What is the difference between the highest and the second highest ODA received (in %) of Nepal?
Your response must be concise. 1.07. What is the difference between the highest and the second highest ODA received (in %) in South Africa?
Your response must be concise. 0.03. What is the difference between the highest and the second highest ODA received (in %) of Tonga?
Provide a succinct answer. 2.17. What is the difference between the highest and the lowest ODA received (in %) of Lower middle income?
Provide a succinct answer. 0.32. What is the difference between the highest and the lowest ODA received (in %) of Nepal?
Your response must be concise. 2.52. What is the difference between the highest and the lowest ODA received (in %) in South Africa?
Ensure brevity in your answer.  0.13. What is the difference between the highest and the lowest ODA received (in %) in Tonga?
Keep it short and to the point. 13.23. 